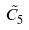Convert formula to latex. <formula><loc_0><loc_0><loc_500><loc_500>\tilde { C } _ { 5 }</formula> 